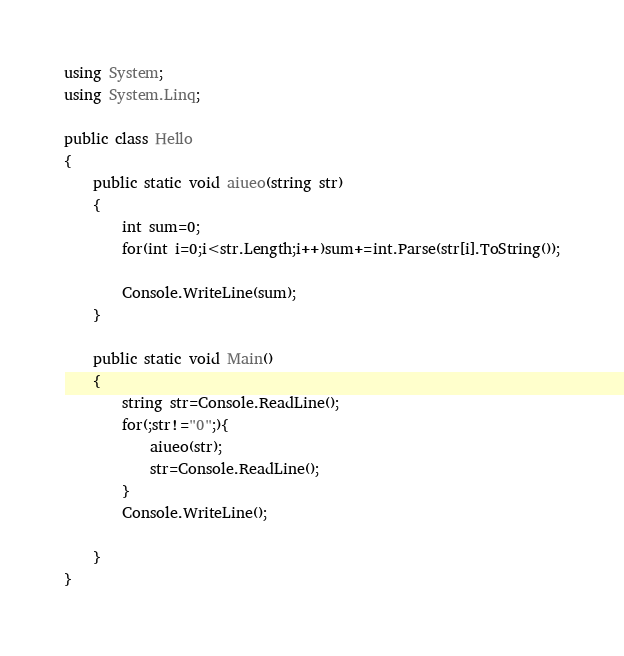<code> <loc_0><loc_0><loc_500><loc_500><_C#_>using System;
using System.Linq;

public class Hello
{
    public static void aiueo(string str)
    {
        int sum=0;
        for(int i=0;i<str.Length;i++)sum+=int.Parse(str[i].ToString());
        
        Console.WriteLine(sum);
    }
    
    public static void Main()
    {
        string str=Console.ReadLine();
        for(;str!="0";){
            aiueo(str);
            str=Console.ReadLine();
        }
        Console.WriteLine();
        
    }
}
</code> 